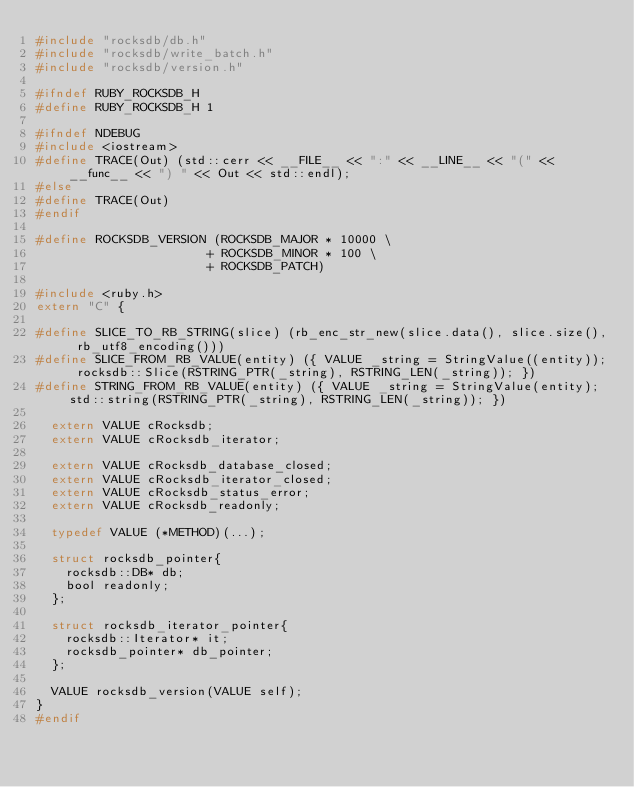<code> <loc_0><loc_0><loc_500><loc_500><_C_>#include "rocksdb/db.h"
#include "rocksdb/write_batch.h"
#include "rocksdb/version.h"

#ifndef RUBY_ROCKSDB_H
#define RUBY_ROCKSDB_H 1

#ifndef NDEBUG
#include <iostream>
#define TRACE(Out) (std::cerr << __FILE__ << ":" << __LINE__ << "(" << __func__ << ") " << Out << std::endl);
#else
#define TRACE(Out)
#endif

#define ROCKSDB_VERSION (ROCKSDB_MAJOR * 10000 \
                       + ROCKSDB_MINOR * 100 \
                       + ROCKSDB_PATCH)

#include <ruby.h>
extern "C" {

#define SLICE_TO_RB_STRING(slice) (rb_enc_str_new(slice.data(), slice.size(), rb_utf8_encoding()))
#define SLICE_FROM_RB_VALUE(entity) ({ VALUE _string = StringValue((entity)); rocksdb::Slice(RSTRING_PTR(_string), RSTRING_LEN(_string)); })
#define STRING_FROM_RB_VALUE(entity) ({ VALUE _string = StringValue(entity); std::string(RSTRING_PTR(_string), RSTRING_LEN(_string)); })

  extern VALUE cRocksdb;
  extern VALUE cRocksdb_iterator;

  extern VALUE cRocksdb_database_closed;
  extern VALUE cRocksdb_iterator_closed;
  extern VALUE cRocksdb_status_error;
  extern VALUE cRocksdb_readonly;

  typedef VALUE (*METHOD)(...);

  struct rocksdb_pointer{
    rocksdb::DB* db;
    bool readonly;
  };

  struct rocksdb_iterator_pointer{
    rocksdb::Iterator* it;
    rocksdb_pointer* db_pointer;
  };

  VALUE rocksdb_version(VALUE self);
}
#endif
</code> 